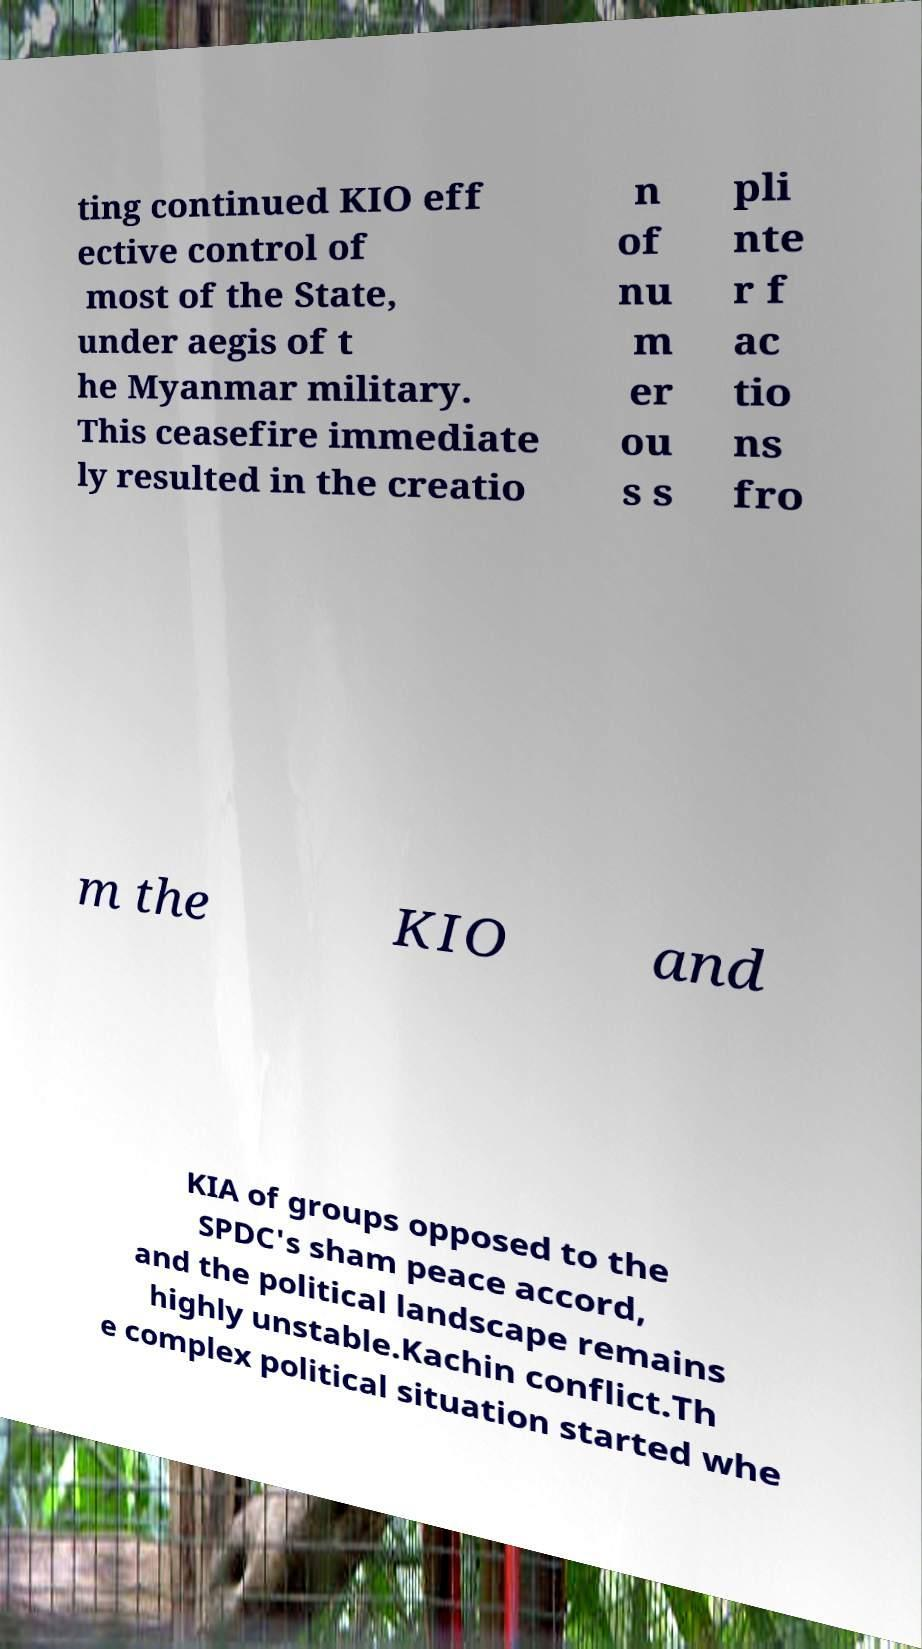Could you extract and type out the text from this image? ting continued KIO eff ective control of most of the State, under aegis of t he Myanmar military. This ceasefire immediate ly resulted in the creatio n of nu m er ou s s pli nte r f ac tio ns fro m the KIO and KIA of groups opposed to the SPDC's sham peace accord, and the political landscape remains highly unstable.Kachin conflict.Th e complex political situation started whe 